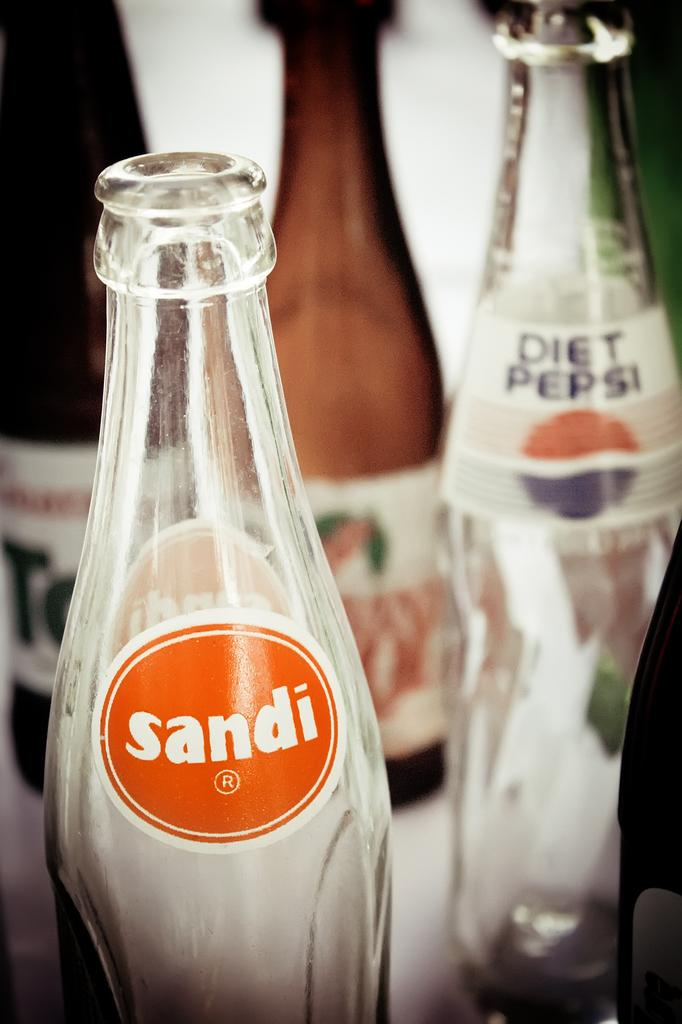Provide a one-sentence caption for the provided image. A Sandi soda bottle sits on a table next to other bottles. 